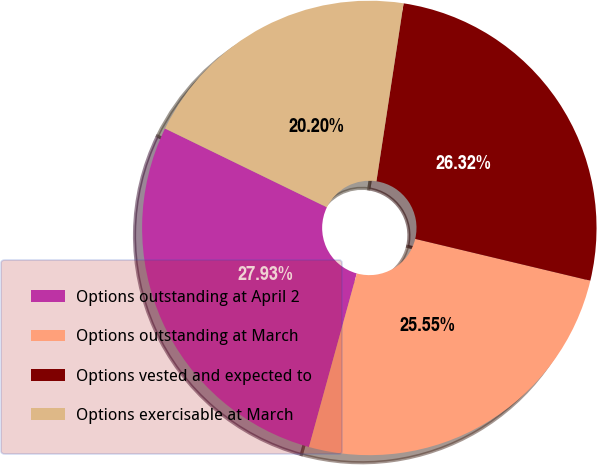Convert chart. <chart><loc_0><loc_0><loc_500><loc_500><pie_chart><fcel>Options outstanding at April 2<fcel>Options outstanding at March<fcel>Options vested and expected to<fcel>Options exercisable at March<nl><fcel>27.93%<fcel>25.55%<fcel>26.32%<fcel>20.2%<nl></chart> 